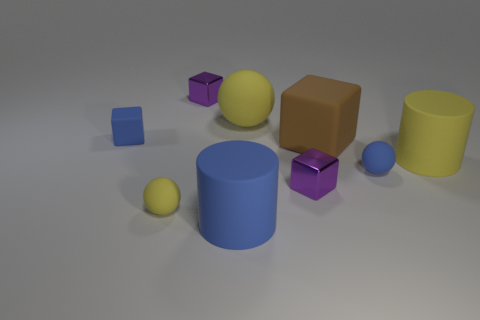Subtract all small blocks. How many blocks are left? 1 Subtract all purple cubes. How many yellow spheres are left? 2 Subtract all brown blocks. How many blocks are left? 3 Subtract 1 balls. How many balls are left? 2 Subtract all gray blocks. Subtract all green cylinders. How many blocks are left? 4 Add 1 tiny cyan rubber balls. How many objects exist? 10 Subtract all cylinders. How many objects are left? 7 Add 3 shiny cubes. How many shiny cubes exist? 5 Subtract 1 blue cylinders. How many objects are left? 8 Subtract all tiny cyan balls. Subtract all yellow objects. How many objects are left? 6 